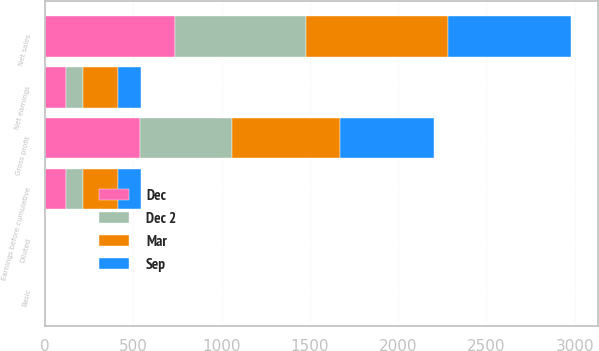Convert chart to OTSL. <chart><loc_0><loc_0><loc_500><loc_500><stacked_bar_chart><ecel><fcel>Net sales<fcel>Gross profit<fcel>Earnings before cumulative<fcel>Net earnings<fcel>Basic<fcel>Diluted<nl><fcel>Dec 2<fcel>742.2<fcel>522.7<fcel>97.6<fcel>97.6<fcel>0.4<fcel>0.4<nl><fcel>Dec<fcel>737.4<fcel>535.5<fcel>116.3<fcel>116.3<fcel>0.48<fcel>0.47<nl><fcel>Sep<fcel>700.2<fcel>531.1<fcel>127.9<fcel>127.9<fcel>0.52<fcel>0.52<nl><fcel>Mar<fcel>801.1<fcel>611.7<fcel>200<fcel>200<fcel>0.82<fcel>0.81<nl></chart> 